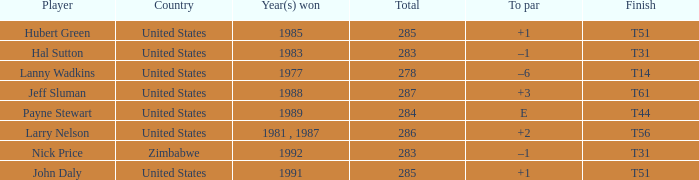What is Finish, when Year(s) Won is "1991"? T51. 